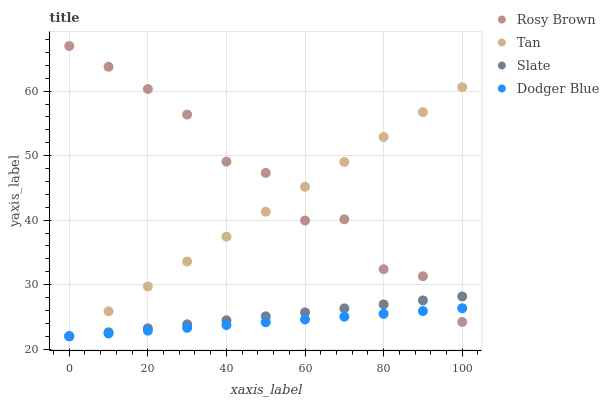Does Dodger Blue have the minimum area under the curve?
Answer yes or no. Yes. Does Rosy Brown have the maximum area under the curve?
Answer yes or no. Yes. Does Rosy Brown have the minimum area under the curve?
Answer yes or no. No. Does Dodger Blue have the maximum area under the curve?
Answer yes or no. No. Is Slate the smoothest?
Answer yes or no. Yes. Is Rosy Brown the roughest?
Answer yes or no. Yes. Is Dodger Blue the smoothest?
Answer yes or no. No. Is Dodger Blue the roughest?
Answer yes or no. No. Does Tan have the lowest value?
Answer yes or no. Yes. Does Rosy Brown have the lowest value?
Answer yes or no. No. Does Rosy Brown have the highest value?
Answer yes or no. Yes. Does Dodger Blue have the highest value?
Answer yes or no. No. Does Dodger Blue intersect Rosy Brown?
Answer yes or no. Yes. Is Dodger Blue less than Rosy Brown?
Answer yes or no. No. Is Dodger Blue greater than Rosy Brown?
Answer yes or no. No. 